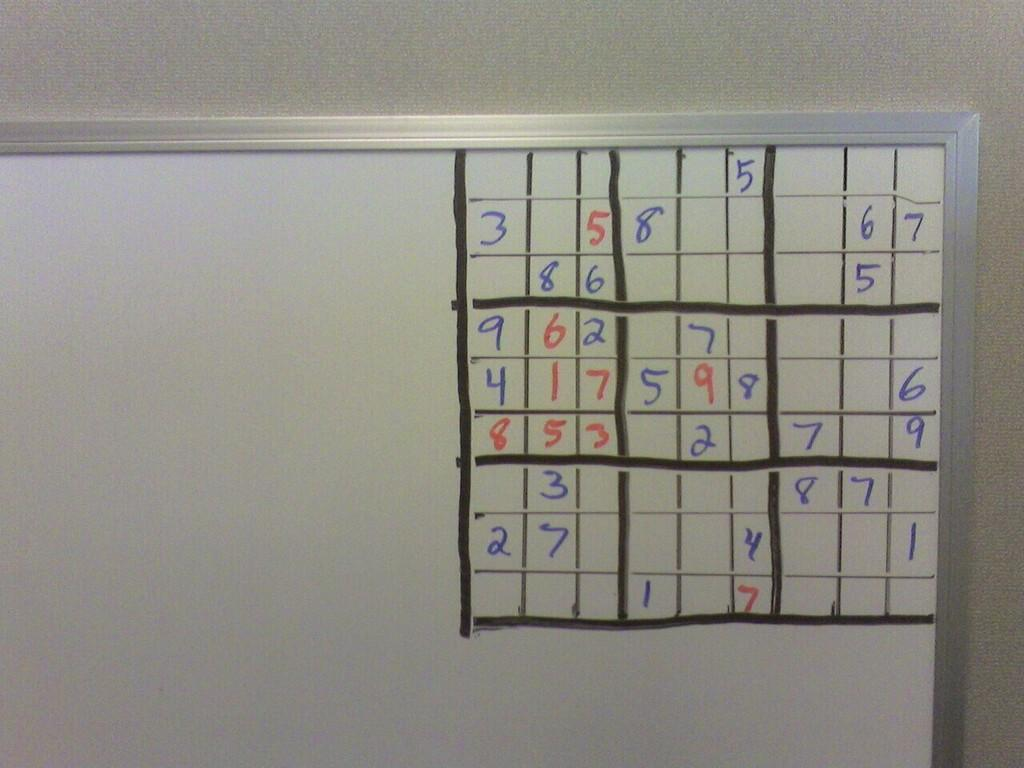<image>
Give a short and clear explanation of the subsequent image. A sudoko board, the numbers on the left side are 3, 9, 4, 8 and 2. 